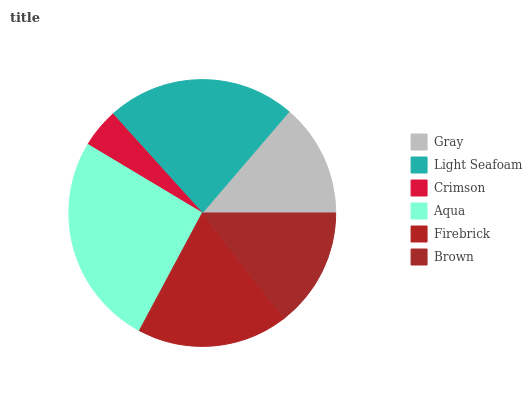Is Crimson the minimum?
Answer yes or no. Yes. Is Aqua the maximum?
Answer yes or no. Yes. Is Light Seafoam the minimum?
Answer yes or no. No. Is Light Seafoam the maximum?
Answer yes or no. No. Is Light Seafoam greater than Gray?
Answer yes or no. Yes. Is Gray less than Light Seafoam?
Answer yes or no. Yes. Is Gray greater than Light Seafoam?
Answer yes or no. No. Is Light Seafoam less than Gray?
Answer yes or no. No. Is Firebrick the high median?
Answer yes or no. Yes. Is Brown the low median?
Answer yes or no. Yes. Is Light Seafoam the high median?
Answer yes or no. No. Is Light Seafoam the low median?
Answer yes or no. No. 